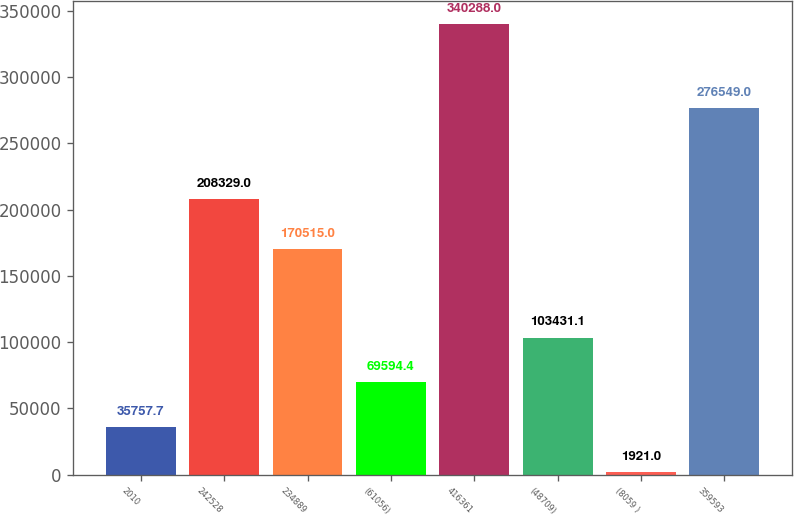<chart> <loc_0><loc_0><loc_500><loc_500><bar_chart><fcel>2010<fcel>242528<fcel>234889<fcel>(61056)<fcel>416361<fcel>(48709)<fcel>(8059 )<fcel>359593<nl><fcel>35757.7<fcel>208329<fcel>170515<fcel>69594.4<fcel>340288<fcel>103431<fcel>1921<fcel>276549<nl></chart> 